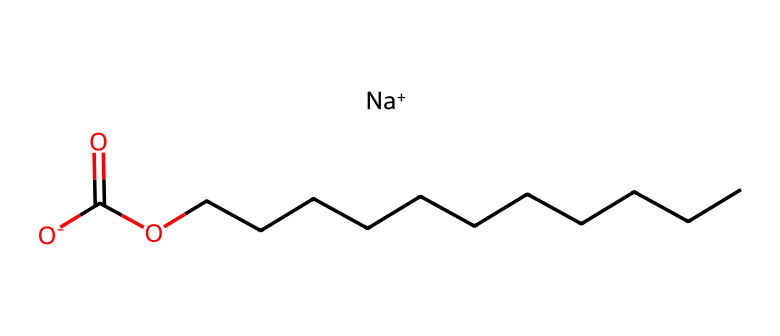what is the total number of carbon atoms in this chemical? Counting the carbon atoms in the provided SMILES, there are 12 carbon atoms present in the long hydrocarbon chain (CCCCCCCCCC) and 1 in the ester functional group (C(=O)). Therefore, the total is 11.
Answer: 12 how many oxygen atoms are present in this chemical? In the SMILES representation, there are two oxygen atoms visible; one is part of the ester (C(=O)) and the other is part of the carboxylate (-O[O-]) group.
Answer: 2 what type of chemical structure does this represent? The presence of a long carbon chain along with a carboxylate functional group typically indicates that this is a fatty acid salt (soap).
Answer: fatty acid salt what charge does the carboxylate group carry? The carboxylate group is represented as –O[O-], which shows that it carries a negative charge due to the presence of the bracketed negatively charged oxygen.
Answer: negative which part of this chemical contributes to its soap properties? The long hydrocarbon chain (CCCCCCCCCC) renders the chemical lipophilic (oil-loving), while the carboxylate end makes it hydrophilic (water-loving), which is crucial for soap properties.
Answer: hydrocarbon chain and carboxylate is there a presence of any functional groups in this chemical? Yes, there are two functional groups: an ester (C(=O)) and a carboxylate (-O[O-]) group.
Answer: yes, ester and carboxylate what is the overall classification of this compound based on its structure? The structure contains a long hydrocarbon chain and a carboxylate group, aligning it with surfactants categorized as anionic surfactants due to the negatively charged carboxylate group.
Answer: anionic surfactant 